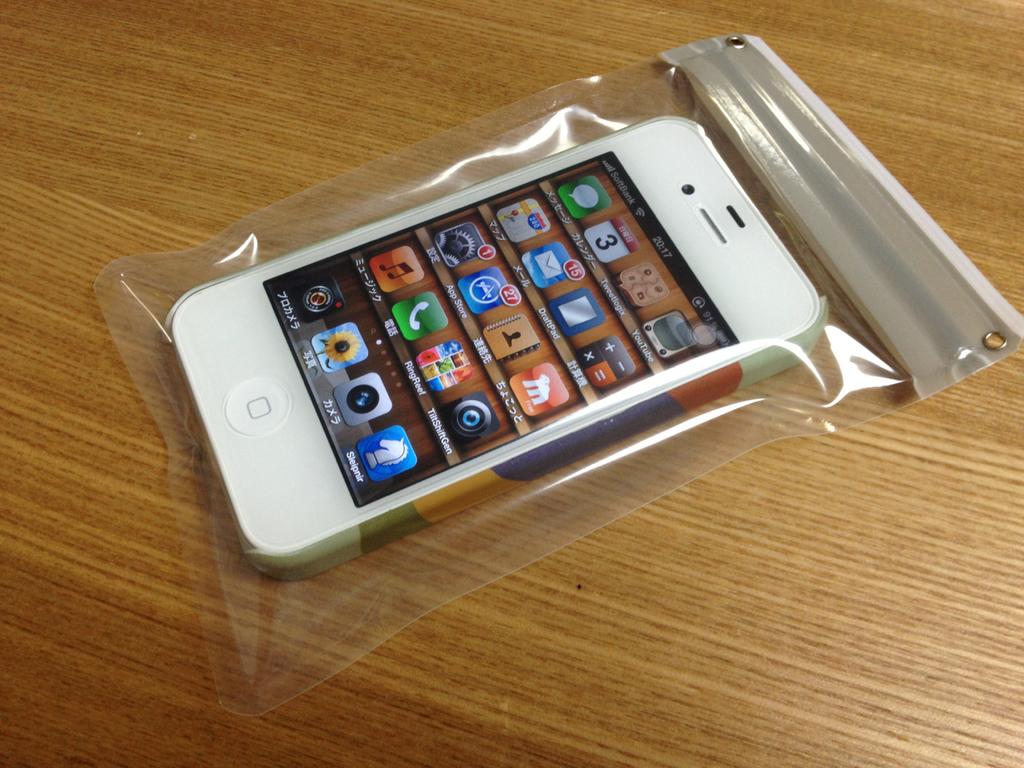What time is on the phone?
Provide a succinct answer. 20:17. What is the date according to the phone?
Provide a short and direct response. 3rd. 